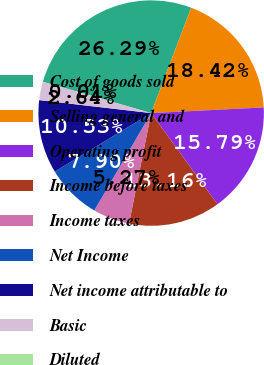Convert chart. <chart><loc_0><loc_0><loc_500><loc_500><pie_chart><fcel>Cost of goods sold<fcel>Selling general and<fcel>Operating profit<fcel>Income before taxes<fcel>Income taxes<fcel>Net Income<fcel>Net income attributable to<fcel>Basic<fcel>Diluted<nl><fcel>26.3%<fcel>18.42%<fcel>15.79%<fcel>13.16%<fcel>5.27%<fcel>7.9%<fcel>10.53%<fcel>2.64%<fcel>0.01%<nl></chart> 